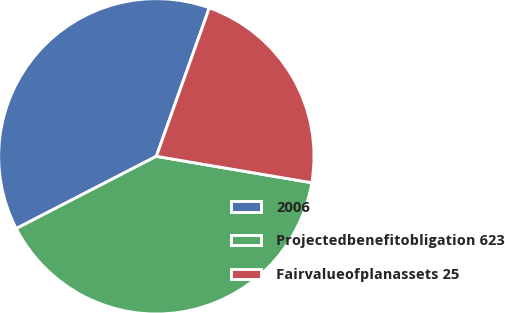Convert chart. <chart><loc_0><loc_0><loc_500><loc_500><pie_chart><fcel>2006<fcel>Projectedbenefitobligation 623<fcel>Fairvalueofplanassets 25<nl><fcel>38.03%<fcel>39.74%<fcel>22.22%<nl></chart> 